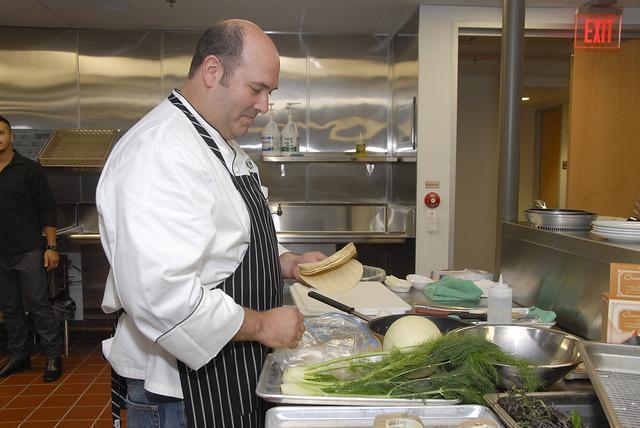What type of wrapper is he putting food in?
Choose the right answer and clarify with the format: 'Answer: answer
Rationale: rationale.'
Options: Tortilla, bun, lettuce wrap, sliced bread. Answer: tortilla.
Rationale: It is round and made from flour 